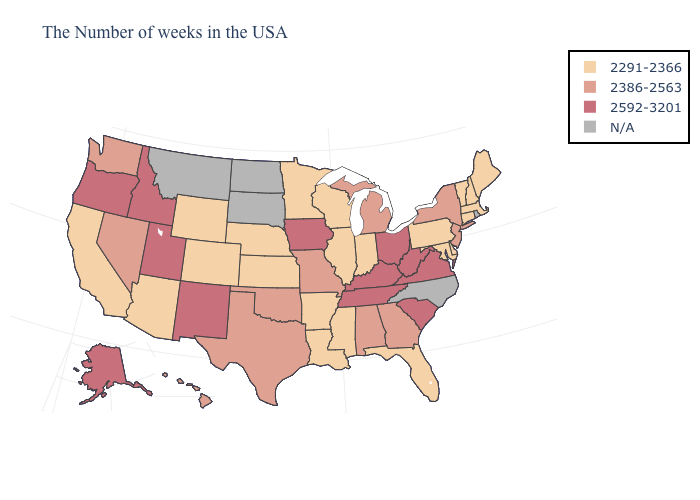Is the legend a continuous bar?
Keep it brief. No. What is the value of Massachusetts?
Write a very short answer. 2291-2366. Name the states that have a value in the range 2592-3201?
Be succinct. Virginia, South Carolina, West Virginia, Ohio, Kentucky, Tennessee, Iowa, New Mexico, Utah, Idaho, Oregon, Alaska. Name the states that have a value in the range 2386-2563?
Answer briefly. New York, New Jersey, Georgia, Michigan, Alabama, Missouri, Oklahoma, Texas, Nevada, Washington, Hawaii. What is the value of Utah?
Write a very short answer. 2592-3201. Name the states that have a value in the range 2291-2366?
Quick response, please. Maine, Massachusetts, New Hampshire, Vermont, Connecticut, Delaware, Maryland, Pennsylvania, Florida, Indiana, Wisconsin, Illinois, Mississippi, Louisiana, Arkansas, Minnesota, Kansas, Nebraska, Wyoming, Colorado, Arizona, California. Name the states that have a value in the range 2592-3201?
Keep it brief. Virginia, South Carolina, West Virginia, Ohio, Kentucky, Tennessee, Iowa, New Mexico, Utah, Idaho, Oregon, Alaska. Is the legend a continuous bar?
Be succinct. No. Does Louisiana have the lowest value in the USA?
Quick response, please. Yes. What is the value of Wisconsin?
Keep it brief. 2291-2366. What is the value of Missouri?
Concise answer only. 2386-2563. 